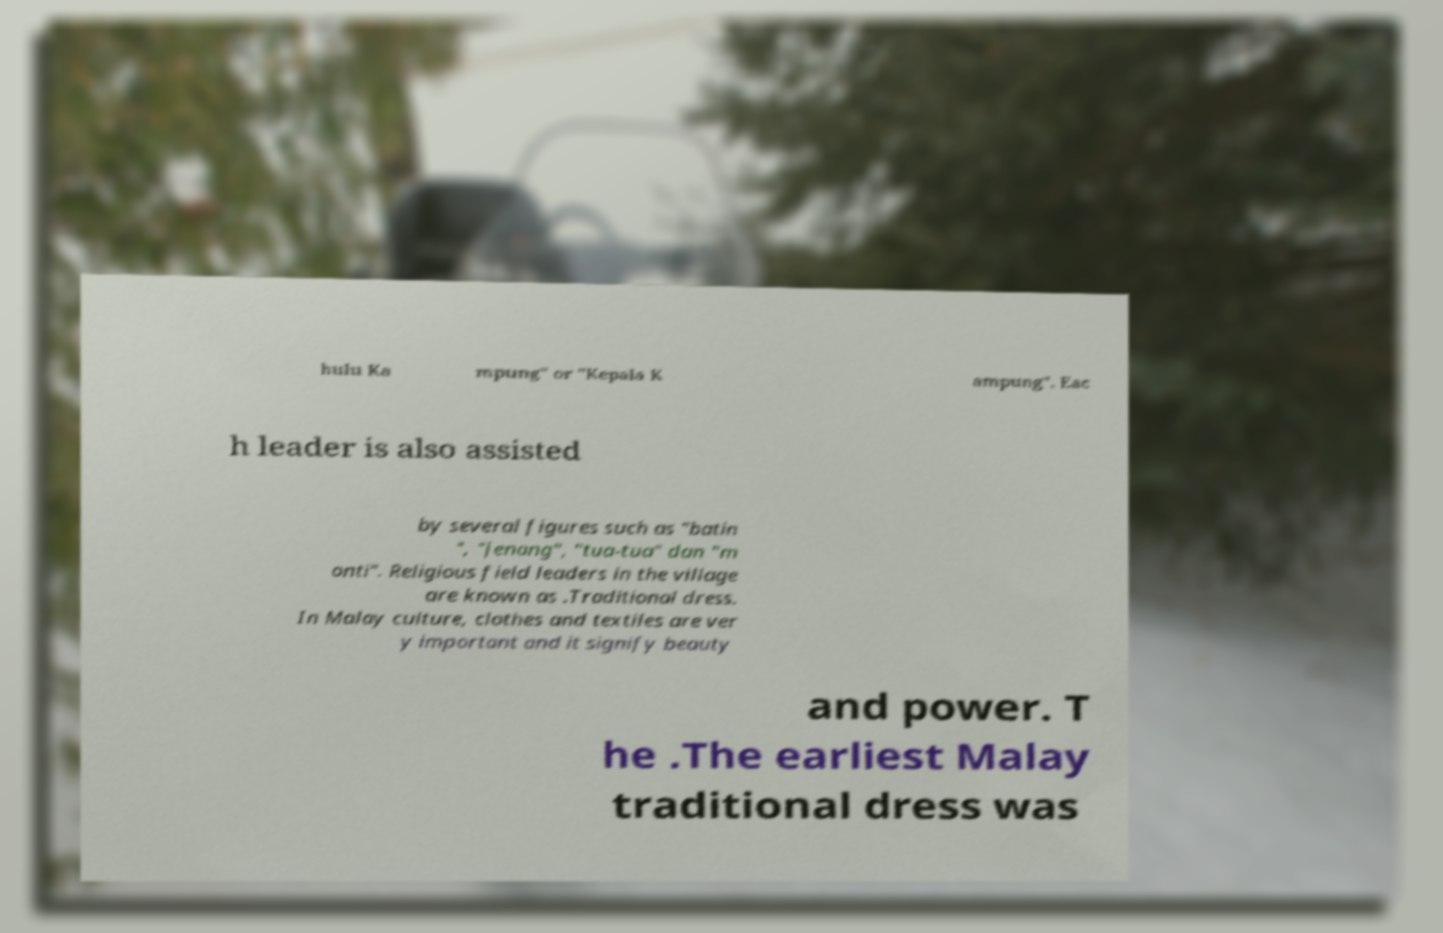Could you extract and type out the text from this image? hulu Ka mpung" or "Kepala K ampung". Eac h leader is also assisted by several figures such as "batin ", "jenang", "tua-tua" dan "m onti". Religious field leaders in the village are known as .Traditional dress. In Malay culture, clothes and textiles are ver y important and it signify beauty and power. T he .The earliest Malay traditional dress was 